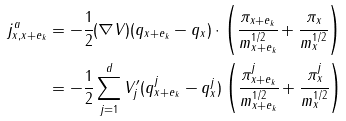<formula> <loc_0><loc_0><loc_500><loc_500>j ^ { a } _ { x , x + e _ { k } } & = - \cfrac { 1 } { 2 } ( \nabla V ) ( q _ { x + e _ { k } } - q _ { x } ) \cdot \left ( \cfrac { \pi _ { x + e _ { k } } } { m ^ { 1 / 2 } _ { x + e _ { k } } } + \cfrac { \pi _ { x } } { m ^ { 1 / 2 } _ { x } } \right ) \\ & = - \frac { 1 } { 2 } \sum _ { j = 1 } ^ { d } V ^ { \prime } _ { j } ( q ^ { j } _ { x + e _ { k } } - q ^ { j } _ { x } ) \left ( \cfrac { \pi ^ { j } _ { x + e _ { k } } } { m ^ { 1 / 2 } _ { x + e _ { k } } } + \cfrac { \pi ^ { j } _ { x } } { m ^ { 1 / 2 } _ { x } } \right )</formula> 